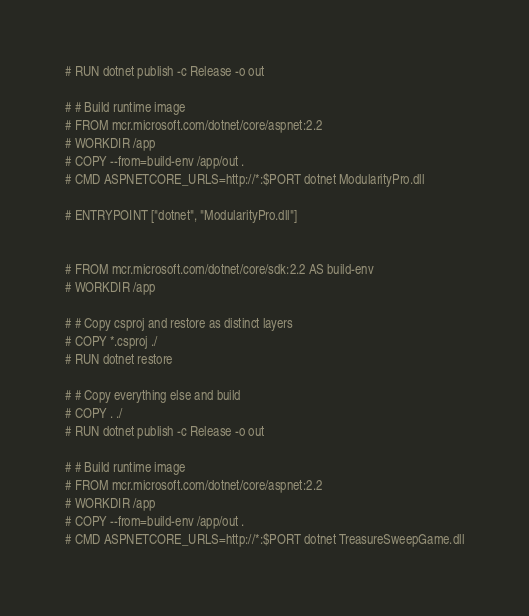<code> <loc_0><loc_0><loc_500><loc_500><_Dockerfile_># RUN dotnet publish -c Release -o out

# # Build runtime image
# FROM mcr.microsoft.com/dotnet/core/aspnet:2.2
# WORKDIR /app
# COPY --from=build-env /app/out .
# CMD ASPNETCORE_URLS=http://*:$PORT dotnet ModularityPro.dll

# ENTRYPOINT ["dotnet", "ModularityPro.dll"]


# FROM mcr.microsoft.com/dotnet/core/sdk:2.2 AS build-env
# WORKDIR /app

# # Copy csproj and restore as distinct layers
# COPY *.csproj ./
# RUN dotnet restore

# # Copy everything else and build
# COPY . ./
# RUN dotnet publish -c Release -o out

# # Build runtime image
# FROM mcr.microsoft.com/dotnet/core/aspnet:2.2
# WORKDIR /app
# COPY --from=build-env /app/out .
# CMD ASPNETCORE_URLS=http://*:$PORT dotnet TreasureSweepGame.dll</code> 